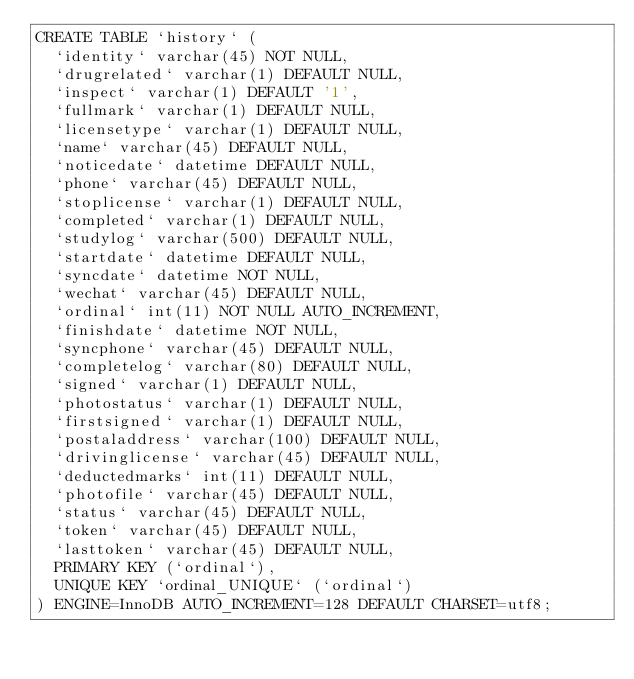<code> <loc_0><loc_0><loc_500><loc_500><_SQL_>CREATE TABLE `history` (
  `identity` varchar(45) NOT NULL,
  `drugrelated` varchar(1) DEFAULT NULL,
  `inspect` varchar(1) DEFAULT '1',
  `fullmark` varchar(1) DEFAULT NULL,
  `licensetype` varchar(1) DEFAULT NULL,
  `name` varchar(45) DEFAULT NULL,
  `noticedate` datetime DEFAULT NULL,
  `phone` varchar(45) DEFAULT NULL,
  `stoplicense` varchar(1) DEFAULT NULL,
  `completed` varchar(1) DEFAULT NULL,
  `studylog` varchar(500) DEFAULT NULL,
  `startdate` datetime DEFAULT NULL,
  `syncdate` datetime NOT NULL,
  `wechat` varchar(45) DEFAULT NULL,
  `ordinal` int(11) NOT NULL AUTO_INCREMENT,
  `finishdate` datetime NOT NULL,
  `syncphone` varchar(45) DEFAULT NULL,
  `completelog` varchar(80) DEFAULT NULL,
  `signed` varchar(1) DEFAULT NULL,
  `photostatus` varchar(1) DEFAULT NULL,
  `firstsigned` varchar(1) DEFAULT NULL,
  `postaladdress` varchar(100) DEFAULT NULL,
  `drivinglicense` varchar(45) DEFAULT NULL,
  `deductedmarks` int(11) DEFAULT NULL,
  `photofile` varchar(45) DEFAULT NULL,
  `status` varchar(45) DEFAULT NULL,
  `token` varchar(45) DEFAULT NULL,
  `lasttoken` varchar(45) DEFAULT NULL,
  PRIMARY KEY (`ordinal`),
  UNIQUE KEY `ordinal_UNIQUE` (`ordinal`)
) ENGINE=InnoDB AUTO_INCREMENT=128 DEFAULT CHARSET=utf8;
</code> 